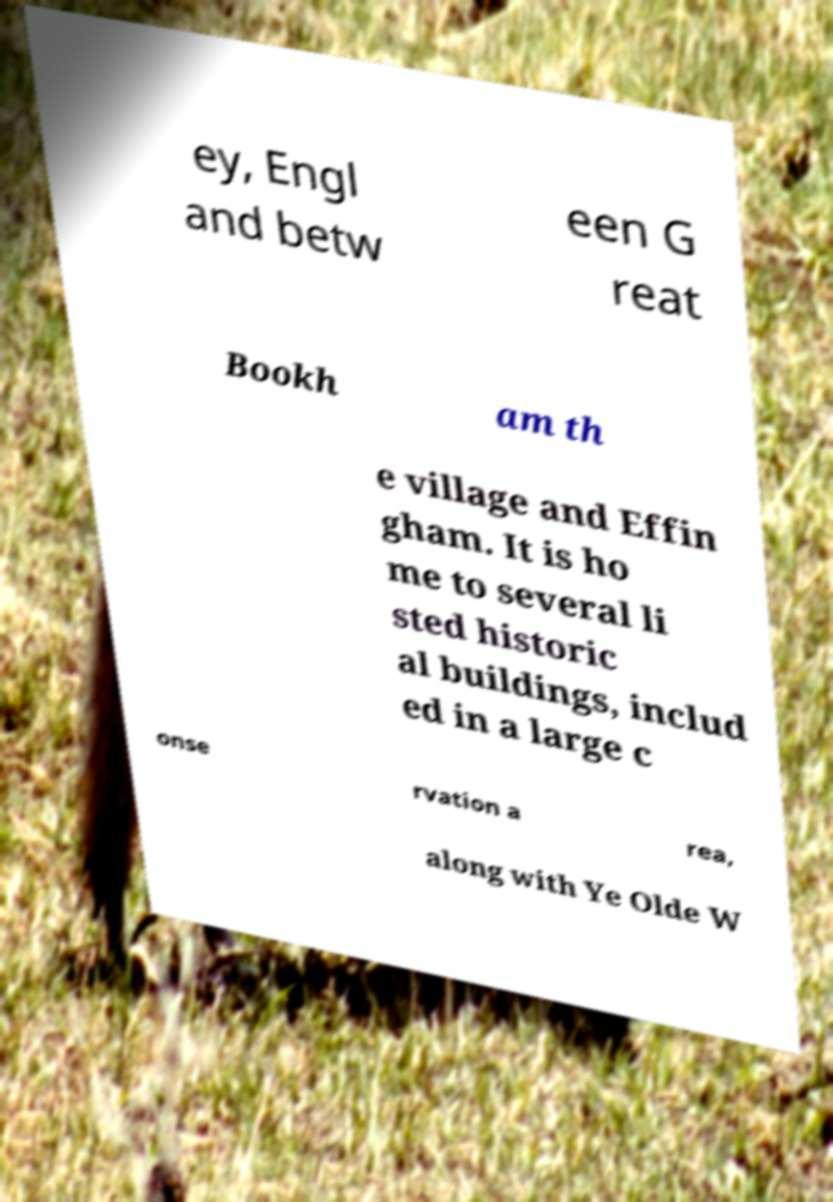What messages or text are displayed in this image? I need them in a readable, typed format. ey, Engl and betw een G reat Bookh am th e village and Effin gham. It is ho me to several li sted historic al buildings, includ ed in a large c onse rvation a rea, along with Ye Olde W 